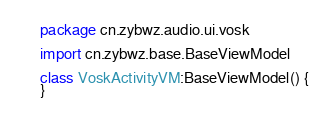<code> <loc_0><loc_0><loc_500><loc_500><_Kotlin_>package cn.zybwz.audio.ui.vosk

import cn.zybwz.base.BaseViewModel

class VoskActivityVM:BaseViewModel() {
}</code> 